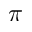Convert formula to latex. <formula><loc_0><loc_0><loc_500><loc_500>\pi</formula> 